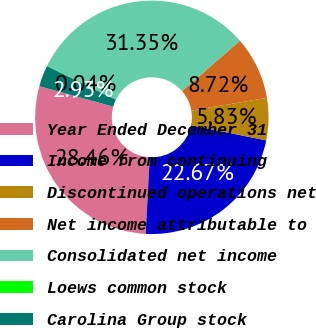<chart> <loc_0><loc_0><loc_500><loc_500><pie_chart><fcel>Year Ended December 31<fcel>Income from continuing<fcel>Discontinued operations net<fcel>Net income attributable to<fcel>Consolidated net income<fcel>Loews common stock<fcel>Carolina Group stock<nl><fcel>28.46%<fcel>22.67%<fcel>5.83%<fcel>8.72%<fcel>31.35%<fcel>0.04%<fcel>2.93%<nl></chart> 